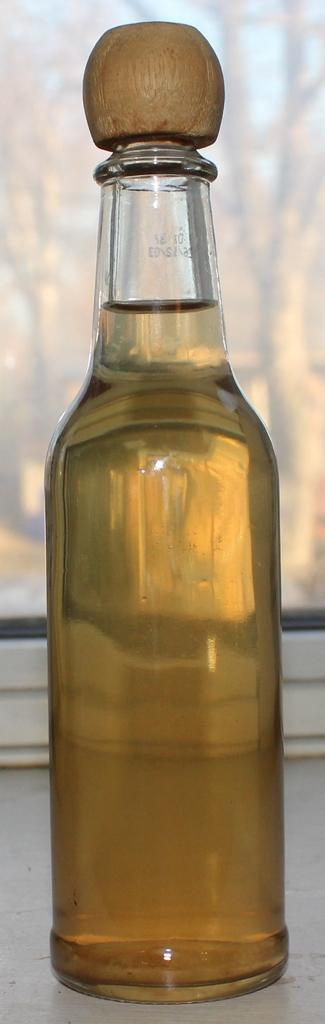What is the main object in the center of the image? There is a bottle in the center of the image. What is inside the bottle? There is liquid inside the bottle. What type of pocket can be seen on the bottle in the image? There is no pocket visible on the bottle in the image. 